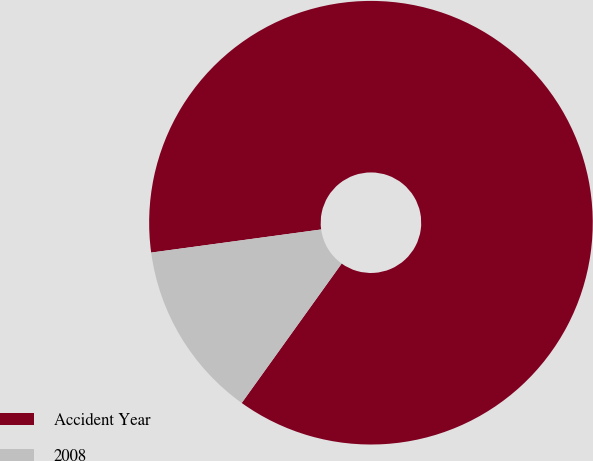Convert chart to OTSL. <chart><loc_0><loc_0><loc_500><loc_500><pie_chart><fcel>Accident Year<fcel>2008<nl><fcel>87.05%<fcel>12.95%<nl></chart> 